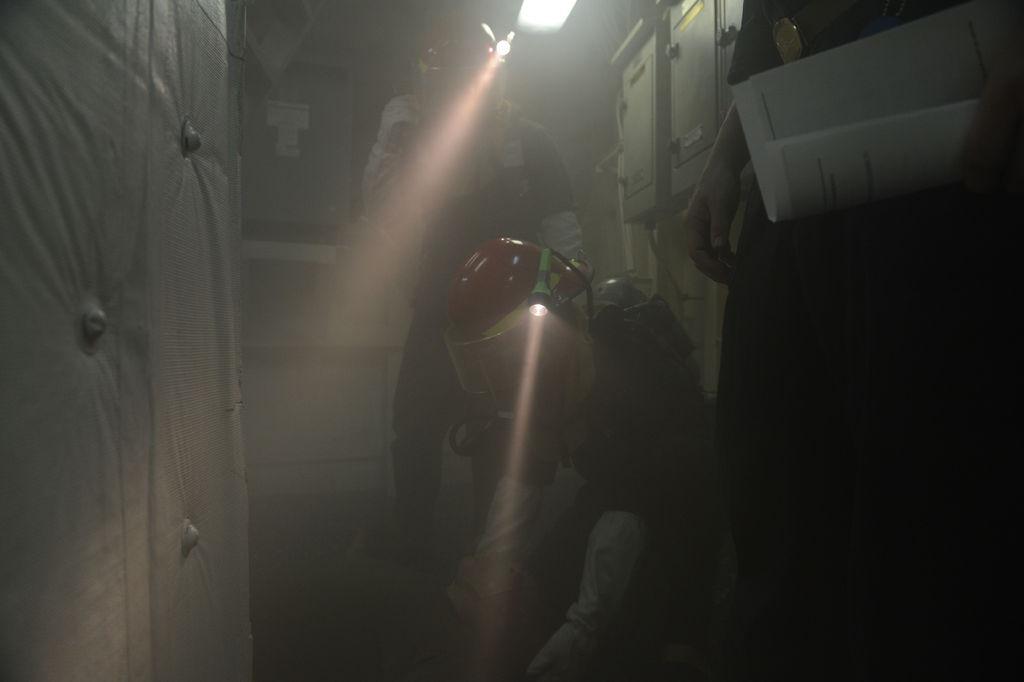How would you summarize this image in a sentence or two? In this image we can see three persons and there are two persons wore helmets. Here we can see torches and a light. There is a dark background and we can see boxes. 